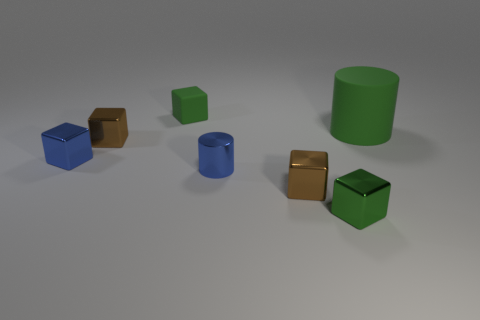Subtract all small green rubber cubes. How many cubes are left? 4 Subtract all blue cubes. How many cubes are left? 4 Subtract all red blocks. Subtract all gray cylinders. How many blocks are left? 5 Add 1 gray matte cylinders. How many objects exist? 8 Subtract all cylinders. How many objects are left? 5 Add 1 small blue blocks. How many small blue blocks exist? 2 Subtract 0 purple spheres. How many objects are left? 7 Subtract all tiny blue shiny cylinders. Subtract all large red balls. How many objects are left? 6 Add 6 big green matte objects. How many big green matte objects are left? 7 